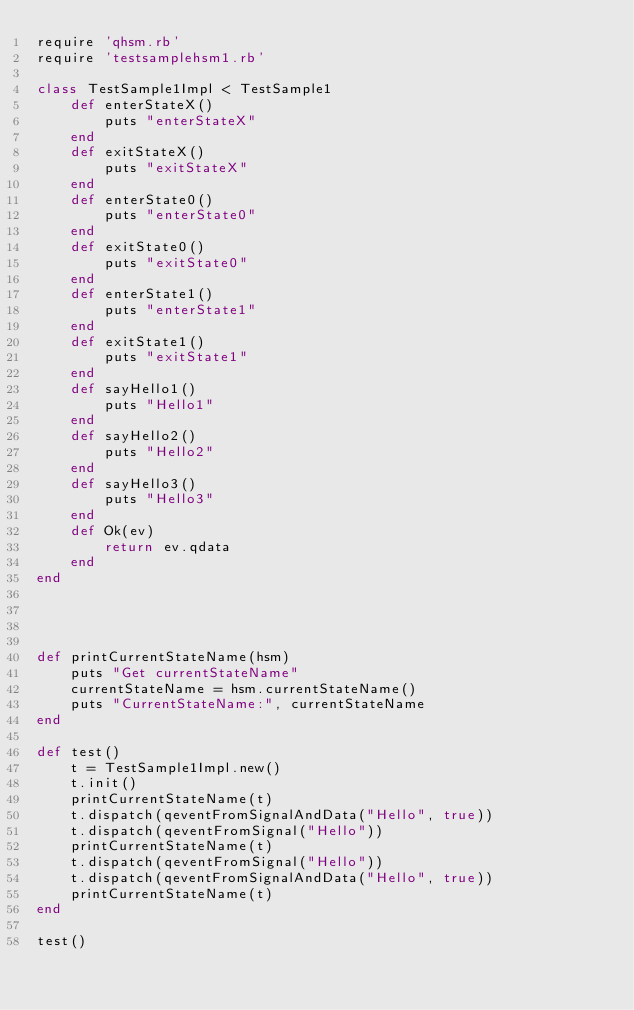<code> <loc_0><loc_0><loc_500><loc_500><_Ruby_>require 'qhsm.rb'
require 'testsamplehsm1.rb'

class TestSample1Impl < TestSample1
    def enterStateX()
        puts "enterStateX"
    end
    def exitStateX()
        puts "exitStateX"
    end
    def enterState0()
        puts "enterState0"
    end
    def exitState0()
        puts "exitState0"
    end
    def enterState1()
        puts "enterState1"
    end
    def exitState1()
        puts "exitState1"
    end
    def sayHello1()
        puts "Hello1"
    end
    def sayHello2()
        puts "Hello2"
    end
    def sayHello3()
        puts "Hello3"
    end
    def Ok(ev)
        return ev.qdata
    end
end


    

def printCurrentStateName(hsm)
    puts "Get currentStateName"
    currentStateName = hsm.currentStateName()
    puts "CurrentStateName:", currentStateName    
end

def test()
    t = TestSample1Impl.new()
    t.init()
    printCurrentStateName(t)
    t.dispatch(qeventFromSignalAndData("Hello", true))
    t.dispatch(qeventFromSignal("Hello"))
    printCurrentStateName(t)
    t.dispatch(qeventFromSignal("Hello"))
    t.dispatch(qeventFromSignalAndData("Hello", true))
    printCurrentStateName(t)
end

test()</code> 